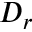<formula> <loc_0><loc_0><loc_500><loc_500>D _ { r }</formula> 